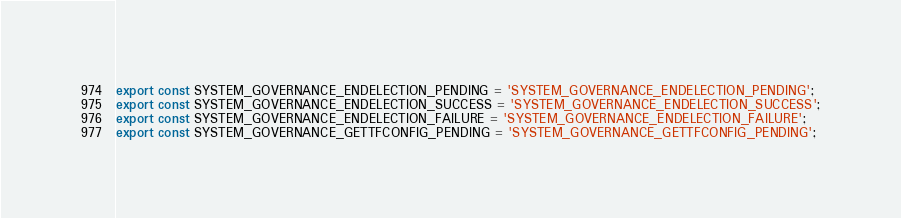<code> <loc_0><loc_0><loc_500><loc_500><_JavaScript_>export const SYSTEM_GOVERNANCE_ENDELECTION_PENDING = 'SYSTEM_GOVERNANCE_ENDELECTION_PENDING';
export const SYSTEM_GOVERNANCE_ENDELECTION_SUCCESS = 'SYSTEM_GOVERNANCE_ENDELECTION_SUCCESS';
export const SYSTEM_GOVERNANCE_ENDELECTION_FAILURE = 'SYSTEM_GOVERNANCE_ENDELECTION_FAILURE';
export const SYSTEM_GOVERNANCE_GETTFCONFIG_PENDING = 'SYSTEM_GOVERNANCE_GETTFCONFIG_PENDING';</code> 